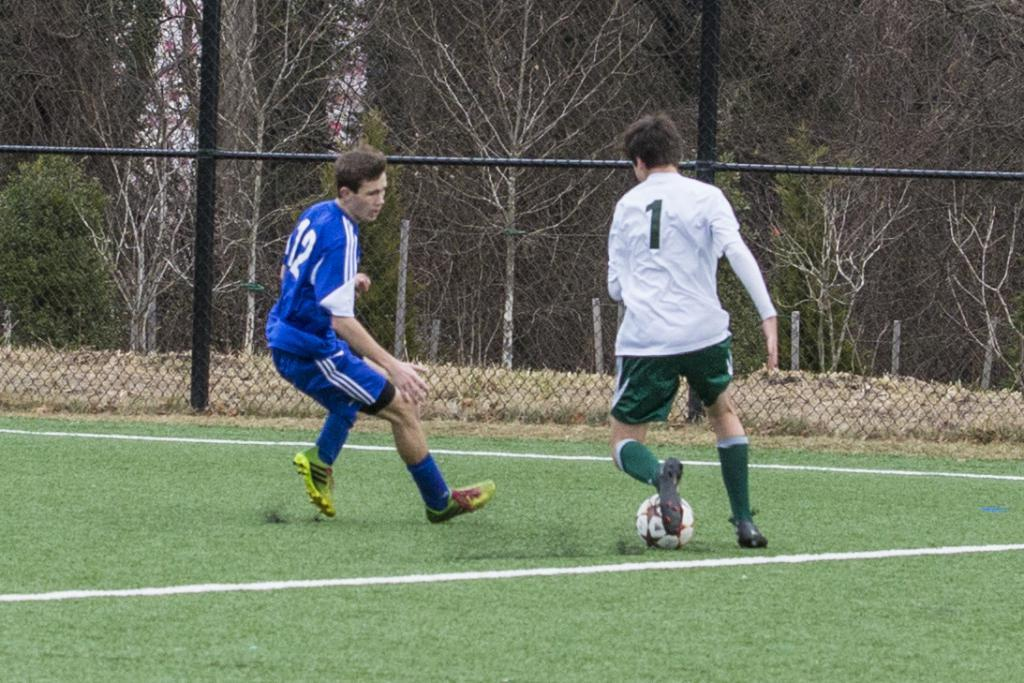<image>
Present a compact description of the photo's key features. Numer one and number twelve oppose each other on a football field. 